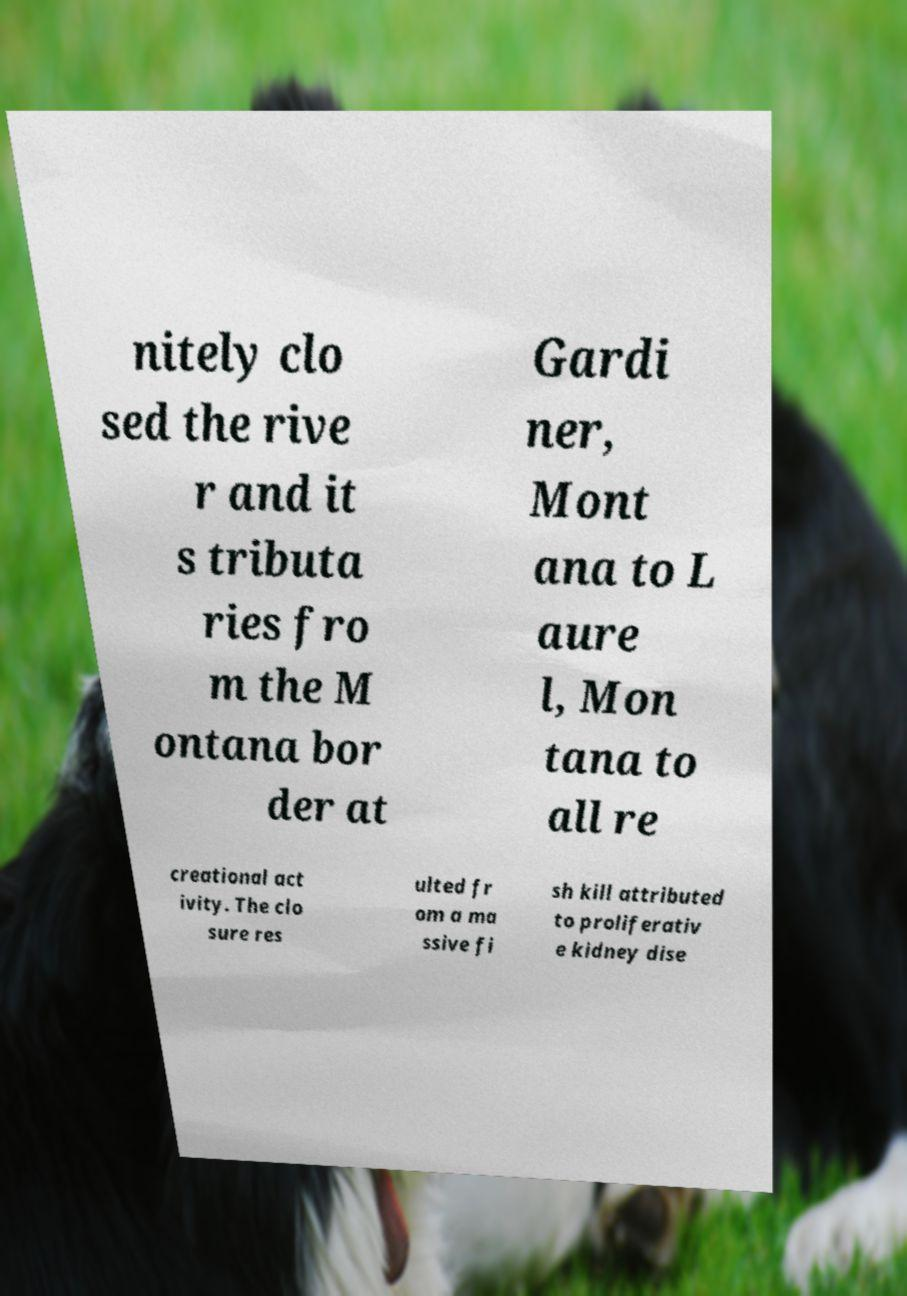For documentation purposes, I need the text within this image transcribed. Could you provide that? nitely clo sed the rive r and it s tributa ries fro m the M ontana bor der at Gardi ner, Mont ana to L aure l, Mon tana to all re creational act ivity. The clo sure res ulted fr om a ma ssive fi sh kill attributed to proliferativ e kidney dise 